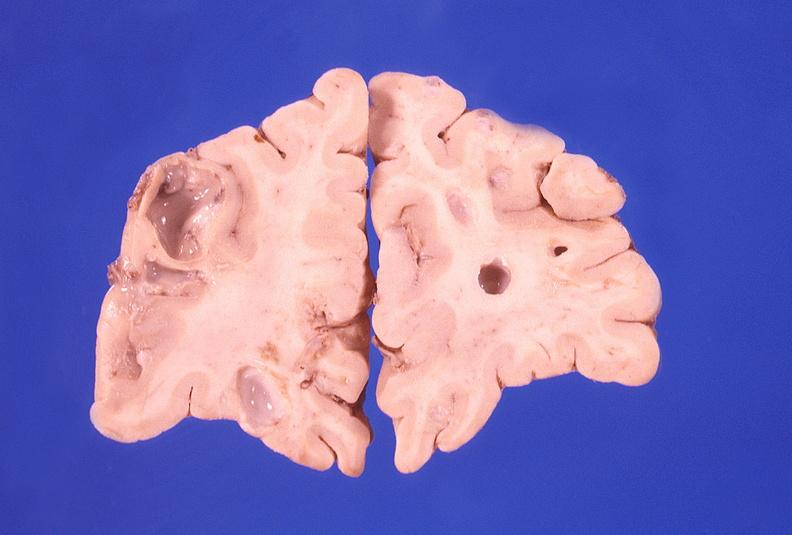what does this image show?
Answer the question using a single word or phrase. Brain abscess 